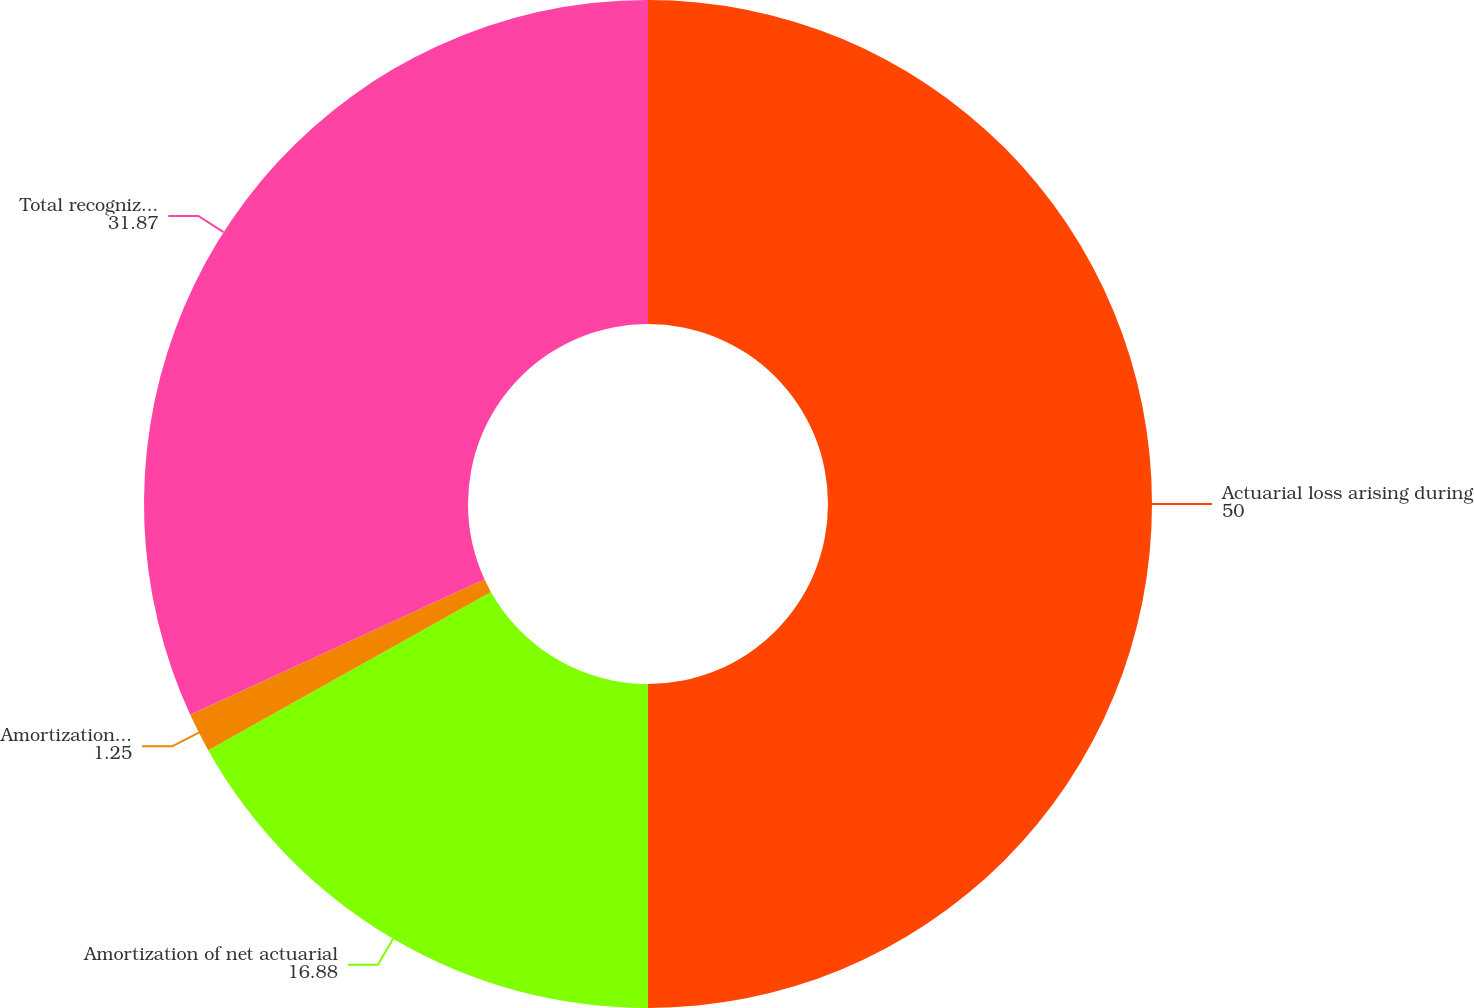Convert chart. <chart><loc_0><loc_0><loc_500><loc_500><pie_chart><fcel>Actuarial loss arising during<fcel>Amortization of net actuarial<fcel>Amortization of prior service<fcel>Total recognized in other<nl><fcel>50.0%<fcel>16.88%<fcel>1.25%<fcel>31.87%<nl></chart> 